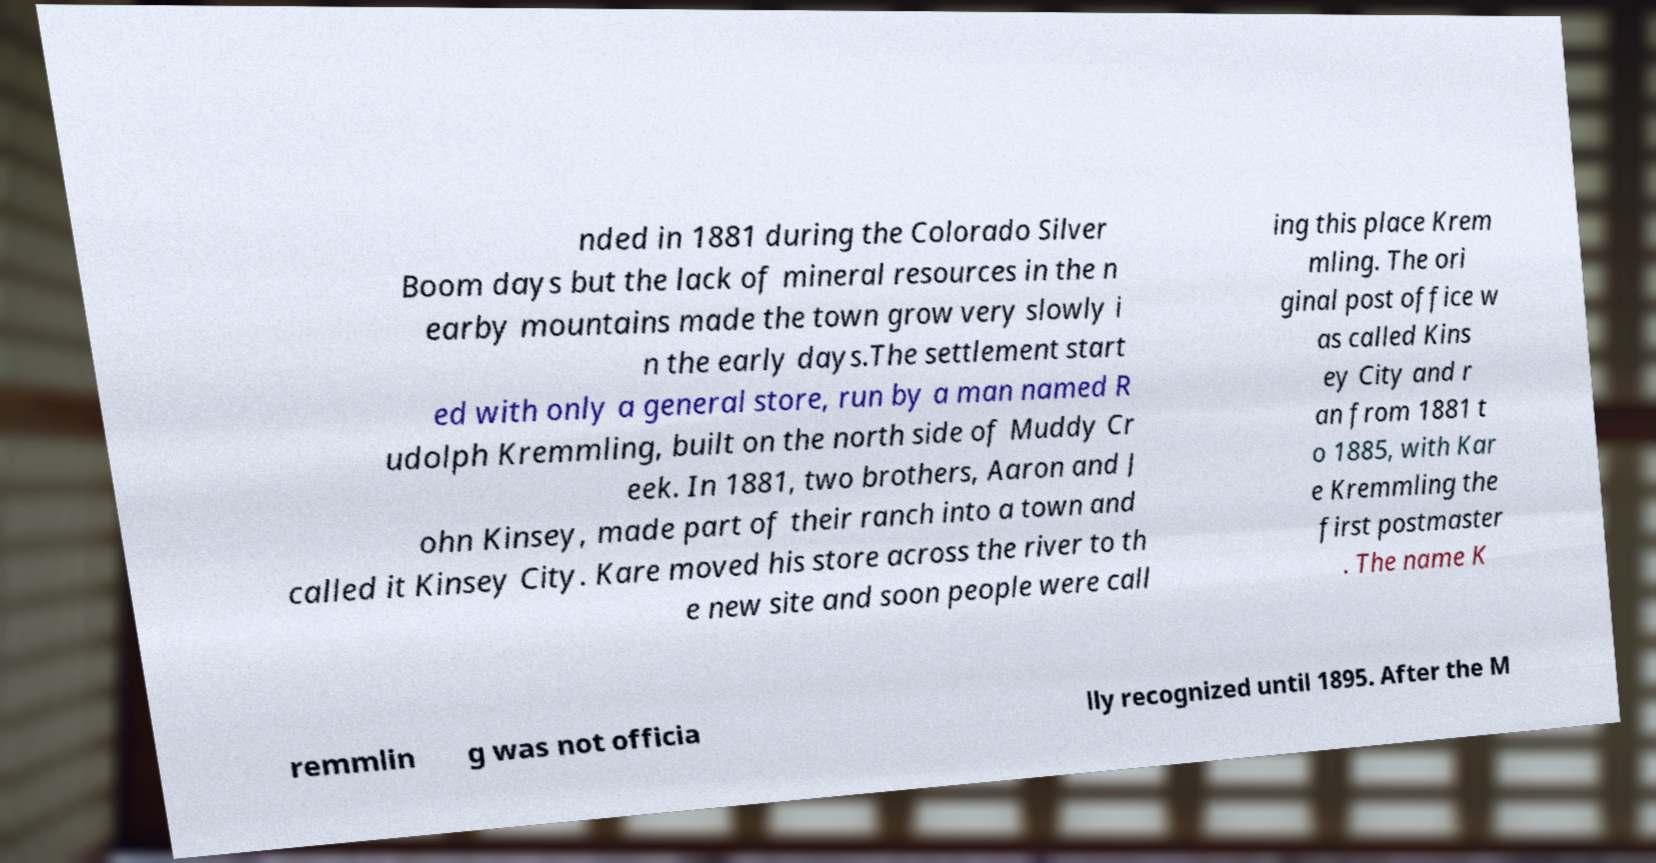Could you extract and type out the text from this image? nded in 1881 during the Colorado Silver Boom days but the lack of mineral resources in the n earby mountains made the town grow very slowly i n the early days.The settlement start ed with only a general store, run by a man named R udolph Kremmling, built on the north side of Muddy Cr eek. In 1881, two brothers, Aaron and J ohn Kinsey, made part of their ranch into a town and called it Kinsey City. Kare moved his store across the river to th e new site and soon people were call ing this place Krem mling. The ori ginal post office w as called Kins ey City and r an from 1881 t o 1885, with Kar e Kremmling the first postmaster . The name K remmlin g was not officia lly recognized until 1895. After the M 